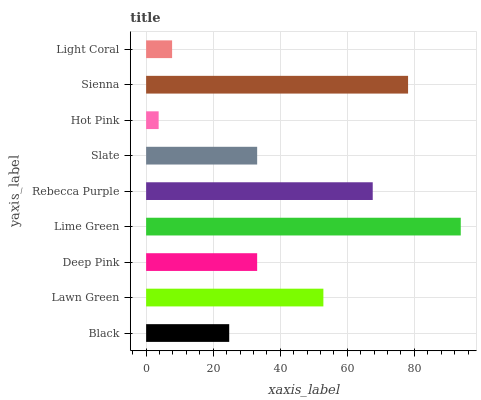Is Hot Pink the minimum?
Answer yes or no. Yes. Is Lime Green the maximum?
Answer yes or no. Yes. Is Lawn Green the minimum?
Answer yes or no. No. Is Lawn Green the maximum?
Answer yes or no. No. Is Lawn Green greater than Black?
Answer yes or no. Yes. Is Black less than Lawn Green?
Answer yes or no. Yes. Is Black greater than Lawn Green?
Answer yes or no. No. Is Lawn Green less than Black?
Answer yes or no. No. Is Slate the high median?
Answer yes or no. Yes. Is Slate the low median?
Answer yes or no. Yes. Is Black the high median?
Answer yes or no. No. Is Black the low median?
Answer yes or no. No. 